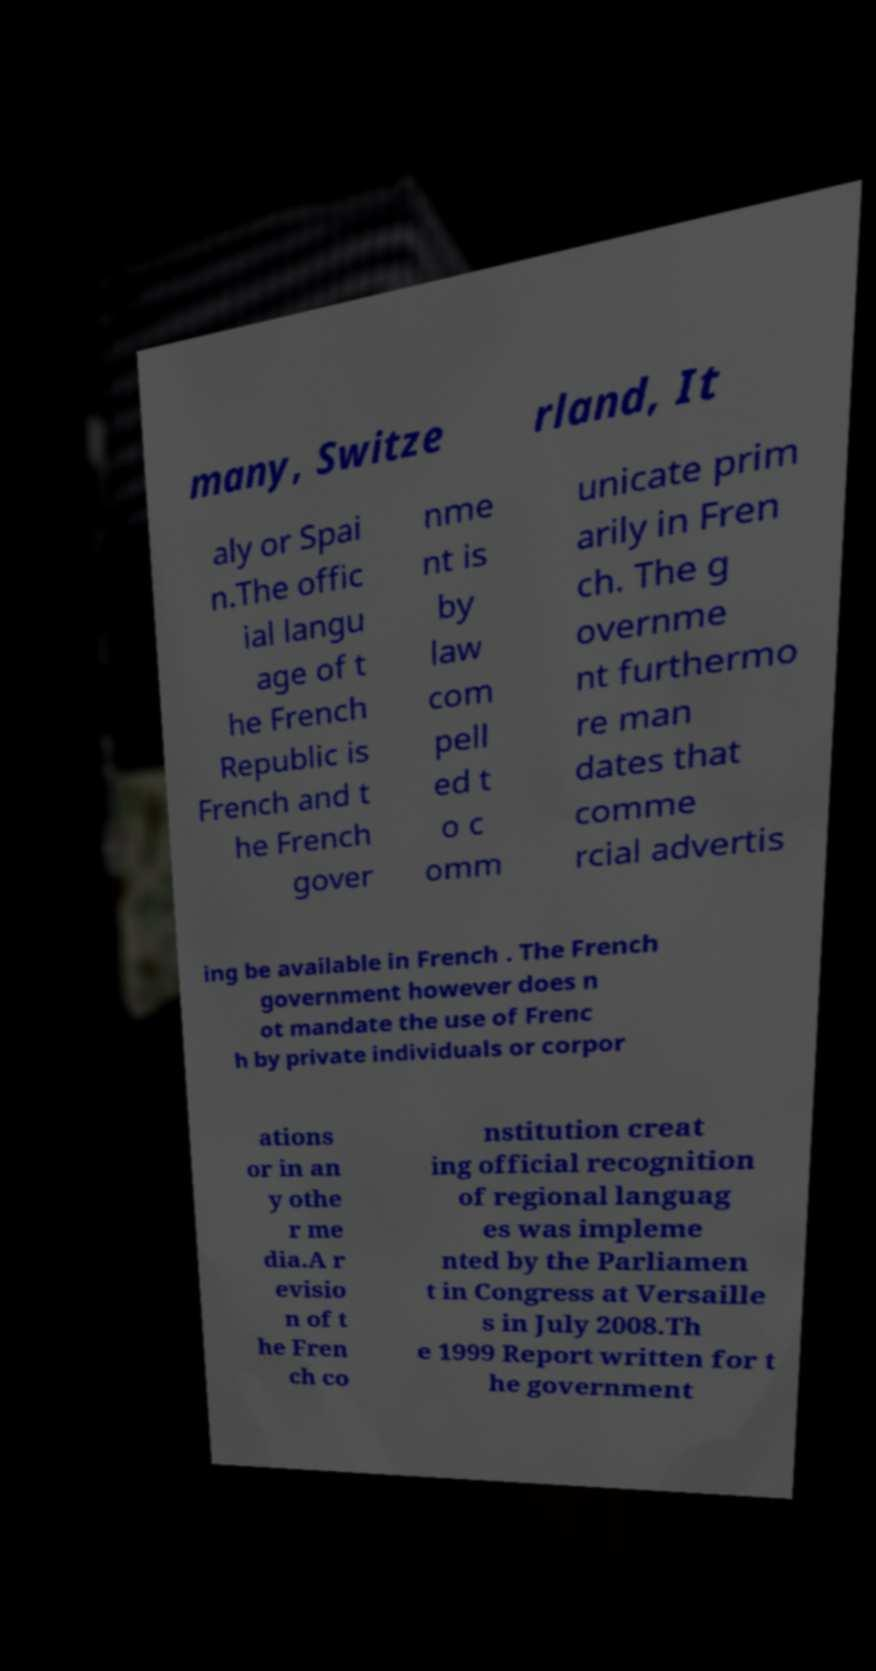Could you assist in decoding the text presented in this image and type it out clearly? many, Switze rland, It aly or Spai n.The offic ial langu age of t he French Republic is French and t he French gover nme nt is by law com pell ed t o c omm unicate prim arily in Fren ch. The g overnme nt furthermo re man dates that comme rcial advertis ing be available in French . The French government however does n ot mandate the use of Frenc h by private individuals or corpor ations or in an y othe r me dia.A r evisio n of t he Fren ch co nstitution creat ing official recognition of regional languag es was impleme nted by the Parliamen t in Congress at Versaille s in July 2008.Th e 1999 Report written for t he government 